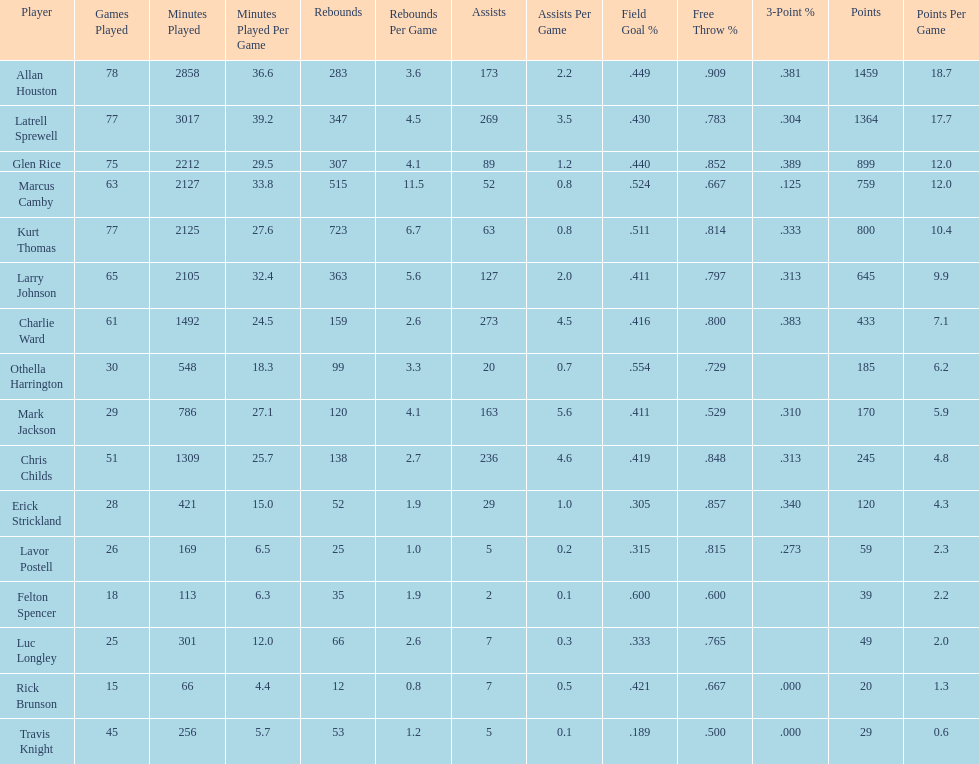How many more games did allan houston play than mark jackson? 49. 